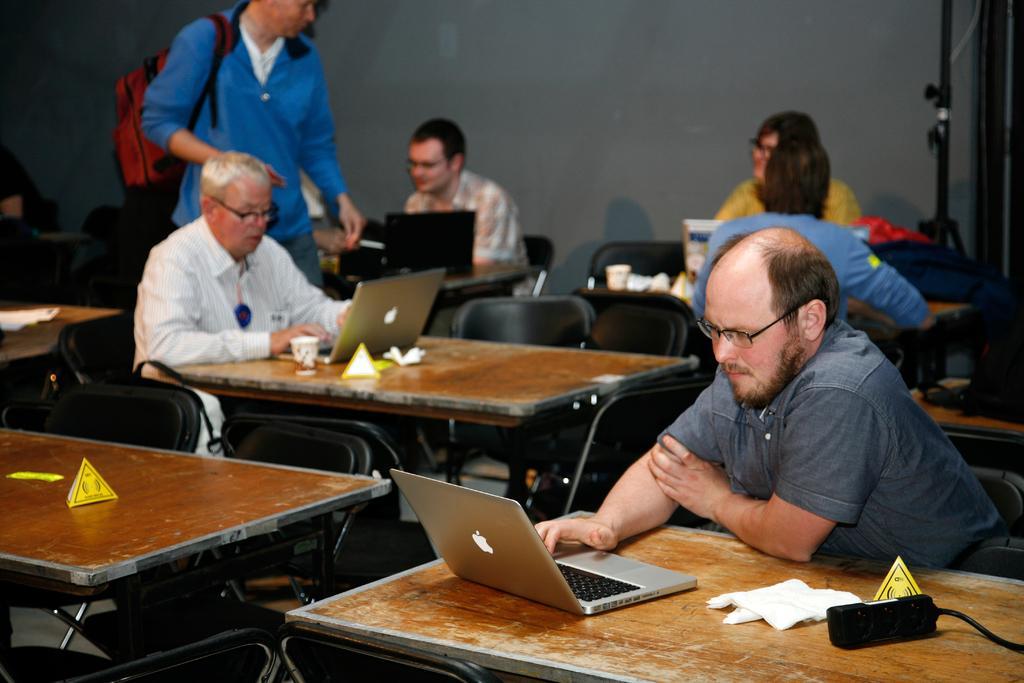In one or two sentences, can you explain what this image depicts? In this picture, we can see a few people sitting, and we can see a person standing and carrying his bag, we can see tables and some objects on table like laptops, tissues, and we can see chairs, wall and some object in the top right corner of the picture. 